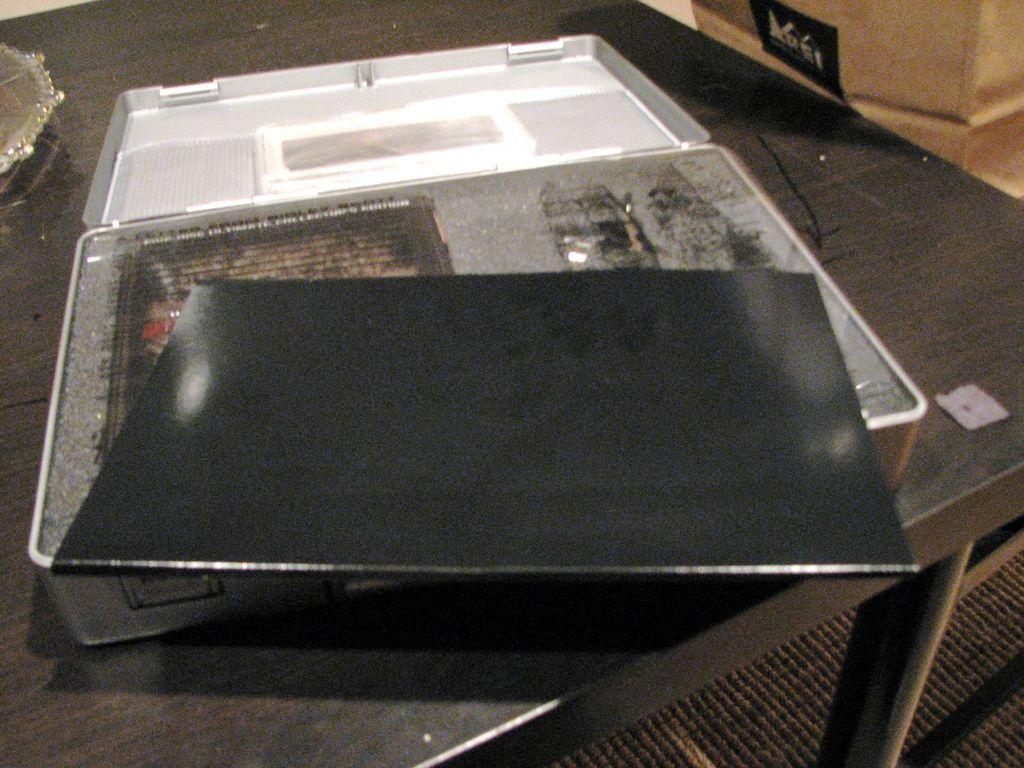Can you describe this image briefly? On the table we can see the suitcase and other object. In that suitcase you can see laptop and book. In the top right corner there is a pillar. At the bottom we can see the carpet. 